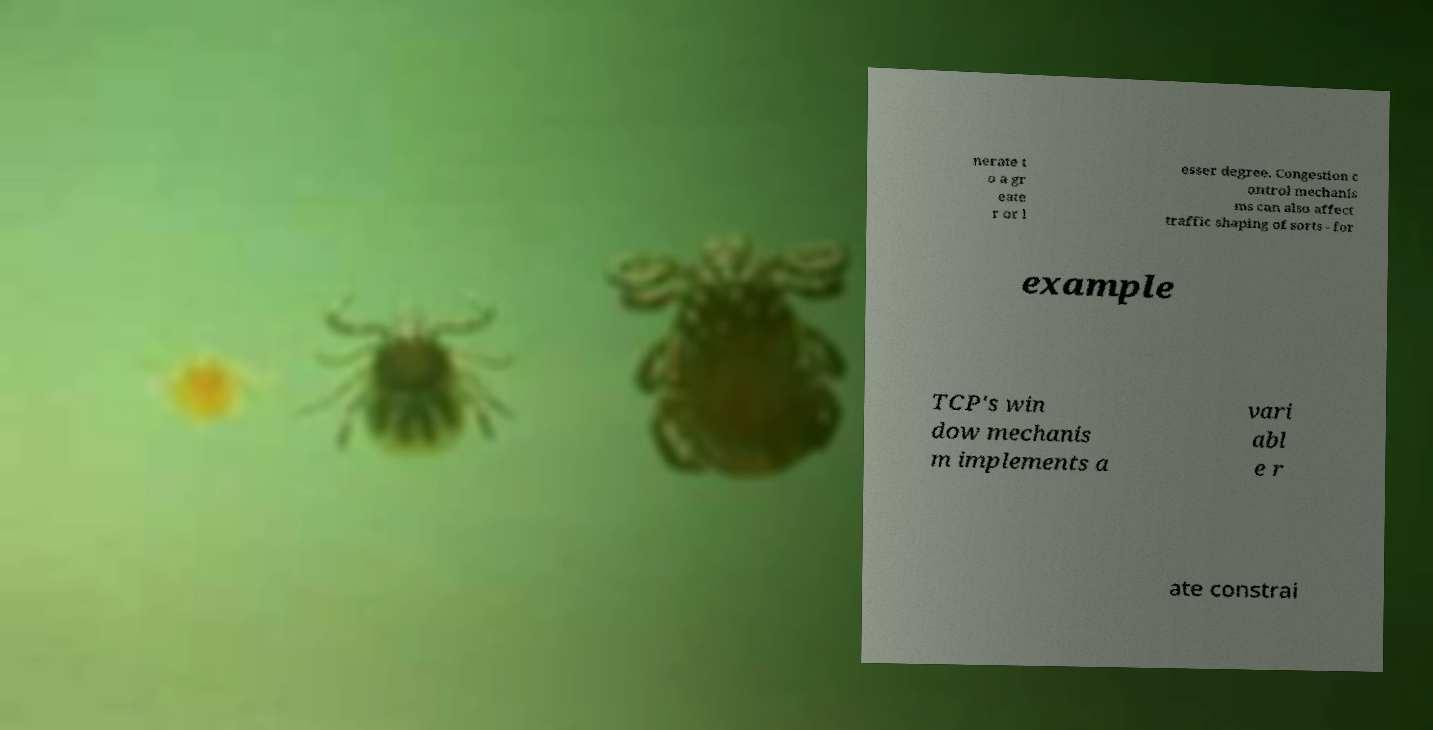Could you extract and type out the text from this image? nerate t o a gr eate r or l esser degree. Congestion c ontrol mechanis ms can also affect traffic shaping of sorts - for example TCP's win dow mechanis m implements a vari abl e r ate constrai 